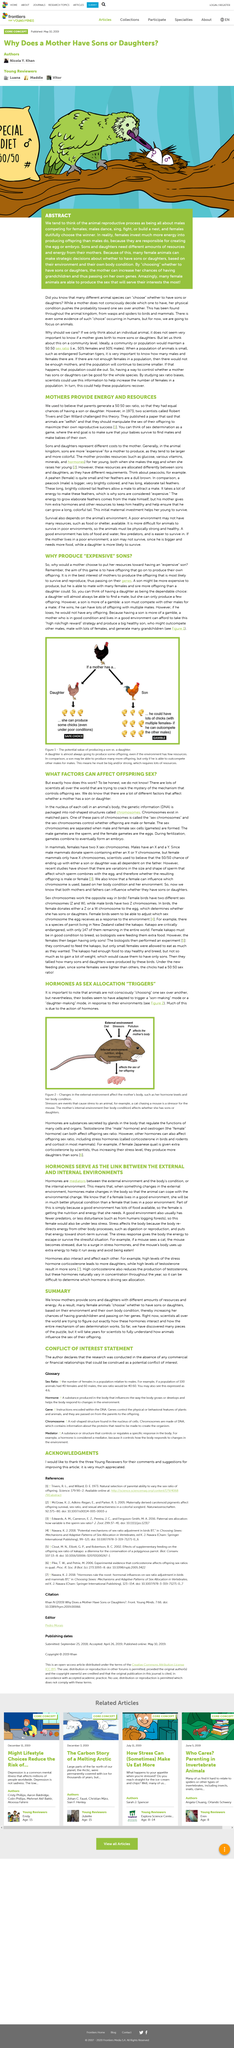Give some essential details in this illustration. According to Robert Trivers and Dan Willard in 1973, they believed that mothers provided energy and resources to their offspring in order to enable their genes to be passed down. They believed that animals are selfish and will maximize their own reproductive success. The female gametes, commonly known as eggs, are the reproductive cells produced by women. The answer to the question "Does a mother's internal environment affect whether she has sons or daughters?" is "Yes, a mother's internal environment affects whether she has sons or daughters. In 1973, a paper was published that challenged the traditional idea that parents generate a 50:50 sex ratio with an equal chance of having a son or daughter. This idea was challenged, and it was found that there are other factors that influence the sex ratio of a child. The sex of offspring is determined by the presence of "sex chromosomes" in the mother, which ultimately determine whether the offspring is male or female. 